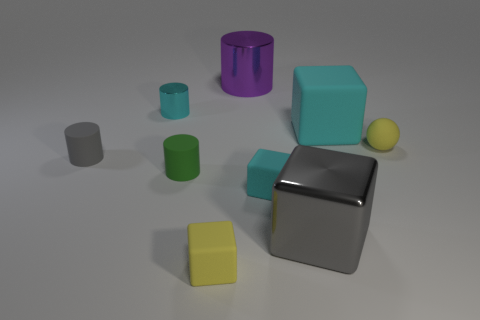There is a cyan matte block that is in front of the block that is behind the cylinder in front of the gray rubber cylinder; how big is it?
Provide a succinct answer. Small. There is a cyan metallic thing that is the same shape as the small green thing; what size is it?
Keep it short and to the point. Small. Does the sphere have the same color as the small matte cube that is on the left side of the purple cylinder?
Provide a short and direct response. Yes. The large block that is made of the same material as the tiny cyan cylinder is what color?
Your answer should be compact. Gray. Do the metal object that is in front of the ball and the big cyan matte object have the same size?
Offer a very short reply. Yes. Is the material of the tiny green object the same as the large object to the left of the big gray metal thing?
Give a very brief answer. No. There is a large shiny thing that is to the right of the tiny cyan rubber object; what is its color?
Ensure brevity in your answer.  Gray. There is a tiny cylinder that is behind the gray rubber cylinder; are there any green objects in front of it?
Offer a very short reply. Yes. There is a metal cylinder on the right side of the small green cylinder; is its color the same as the large cube that is to the left of the large rubber cube?
Provide a short and direct response. No. There is a yellow rubber block; what number of green things are right of it?
Your response must be concise. 0. 